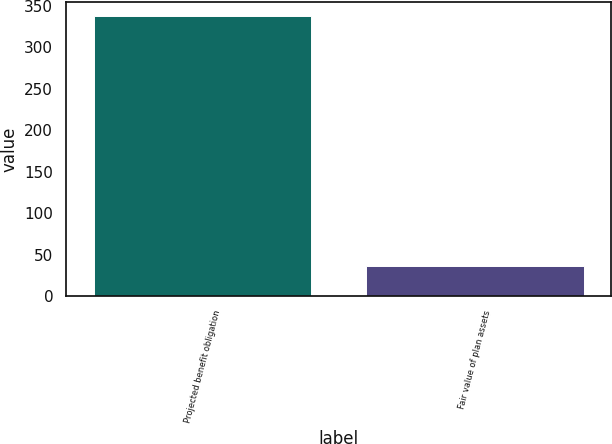Convert chart to OTSL. <chart><loc_0><loc_0><loc_500><loc_500><bar_chart><fcel>Projected benefit obligation<fcel>Fair value of plan assets<nl><fcel>338<fcel>36<nl></chart> 